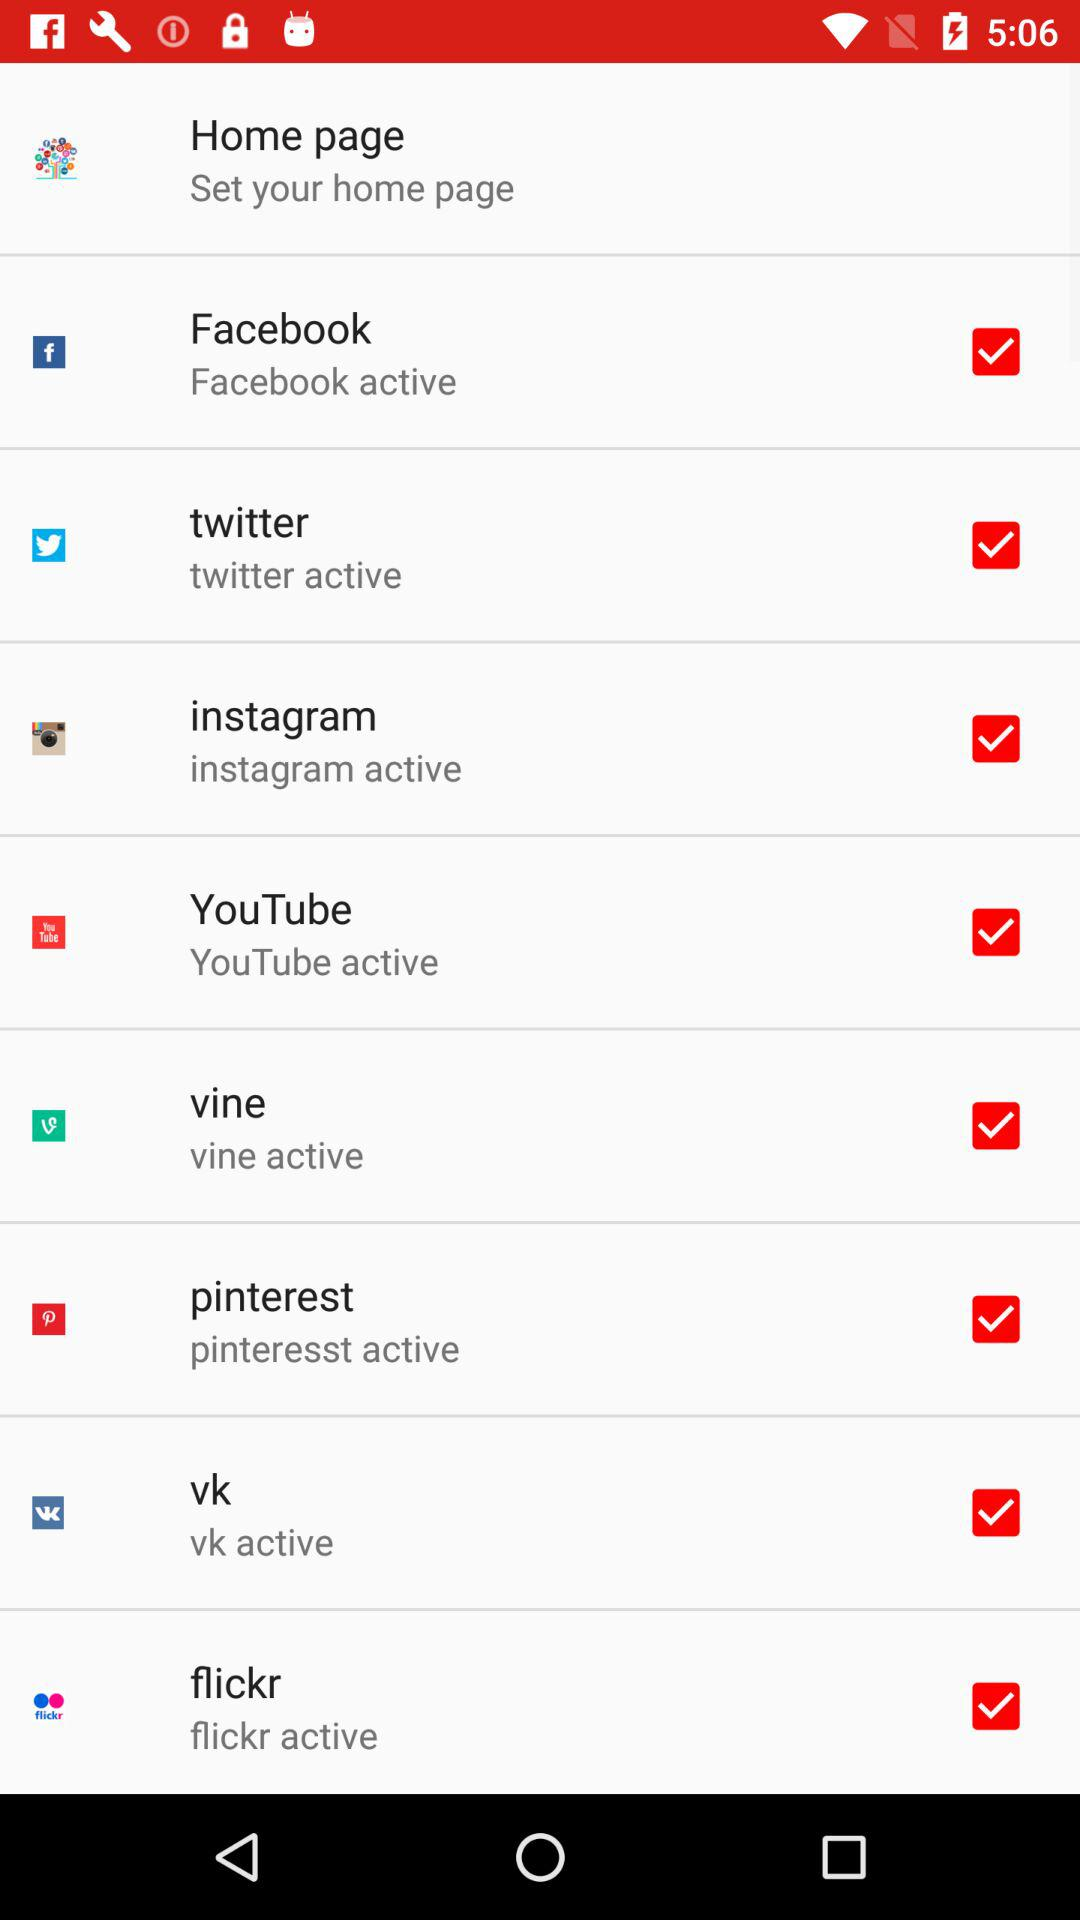Which apps are available? The available apps are "Facebook", "twitter", "instagram", "YouTube", "vine", "pinterest", "vk" and "flickr". 